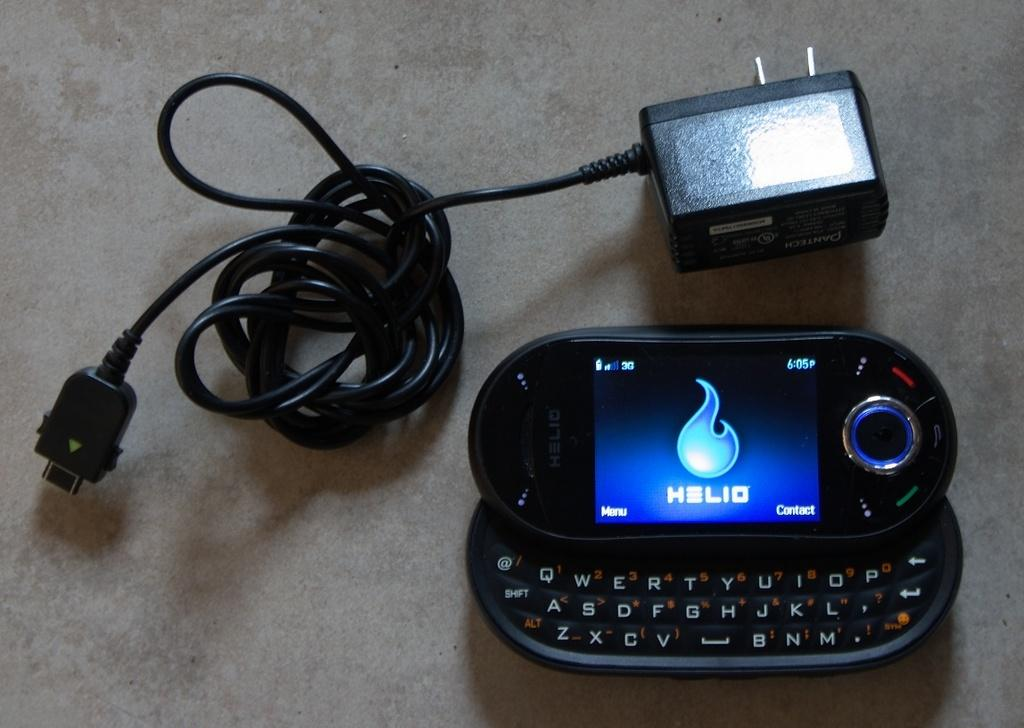<image>
Provide a brief description of the given image. a phone that is open and says Helio on it 